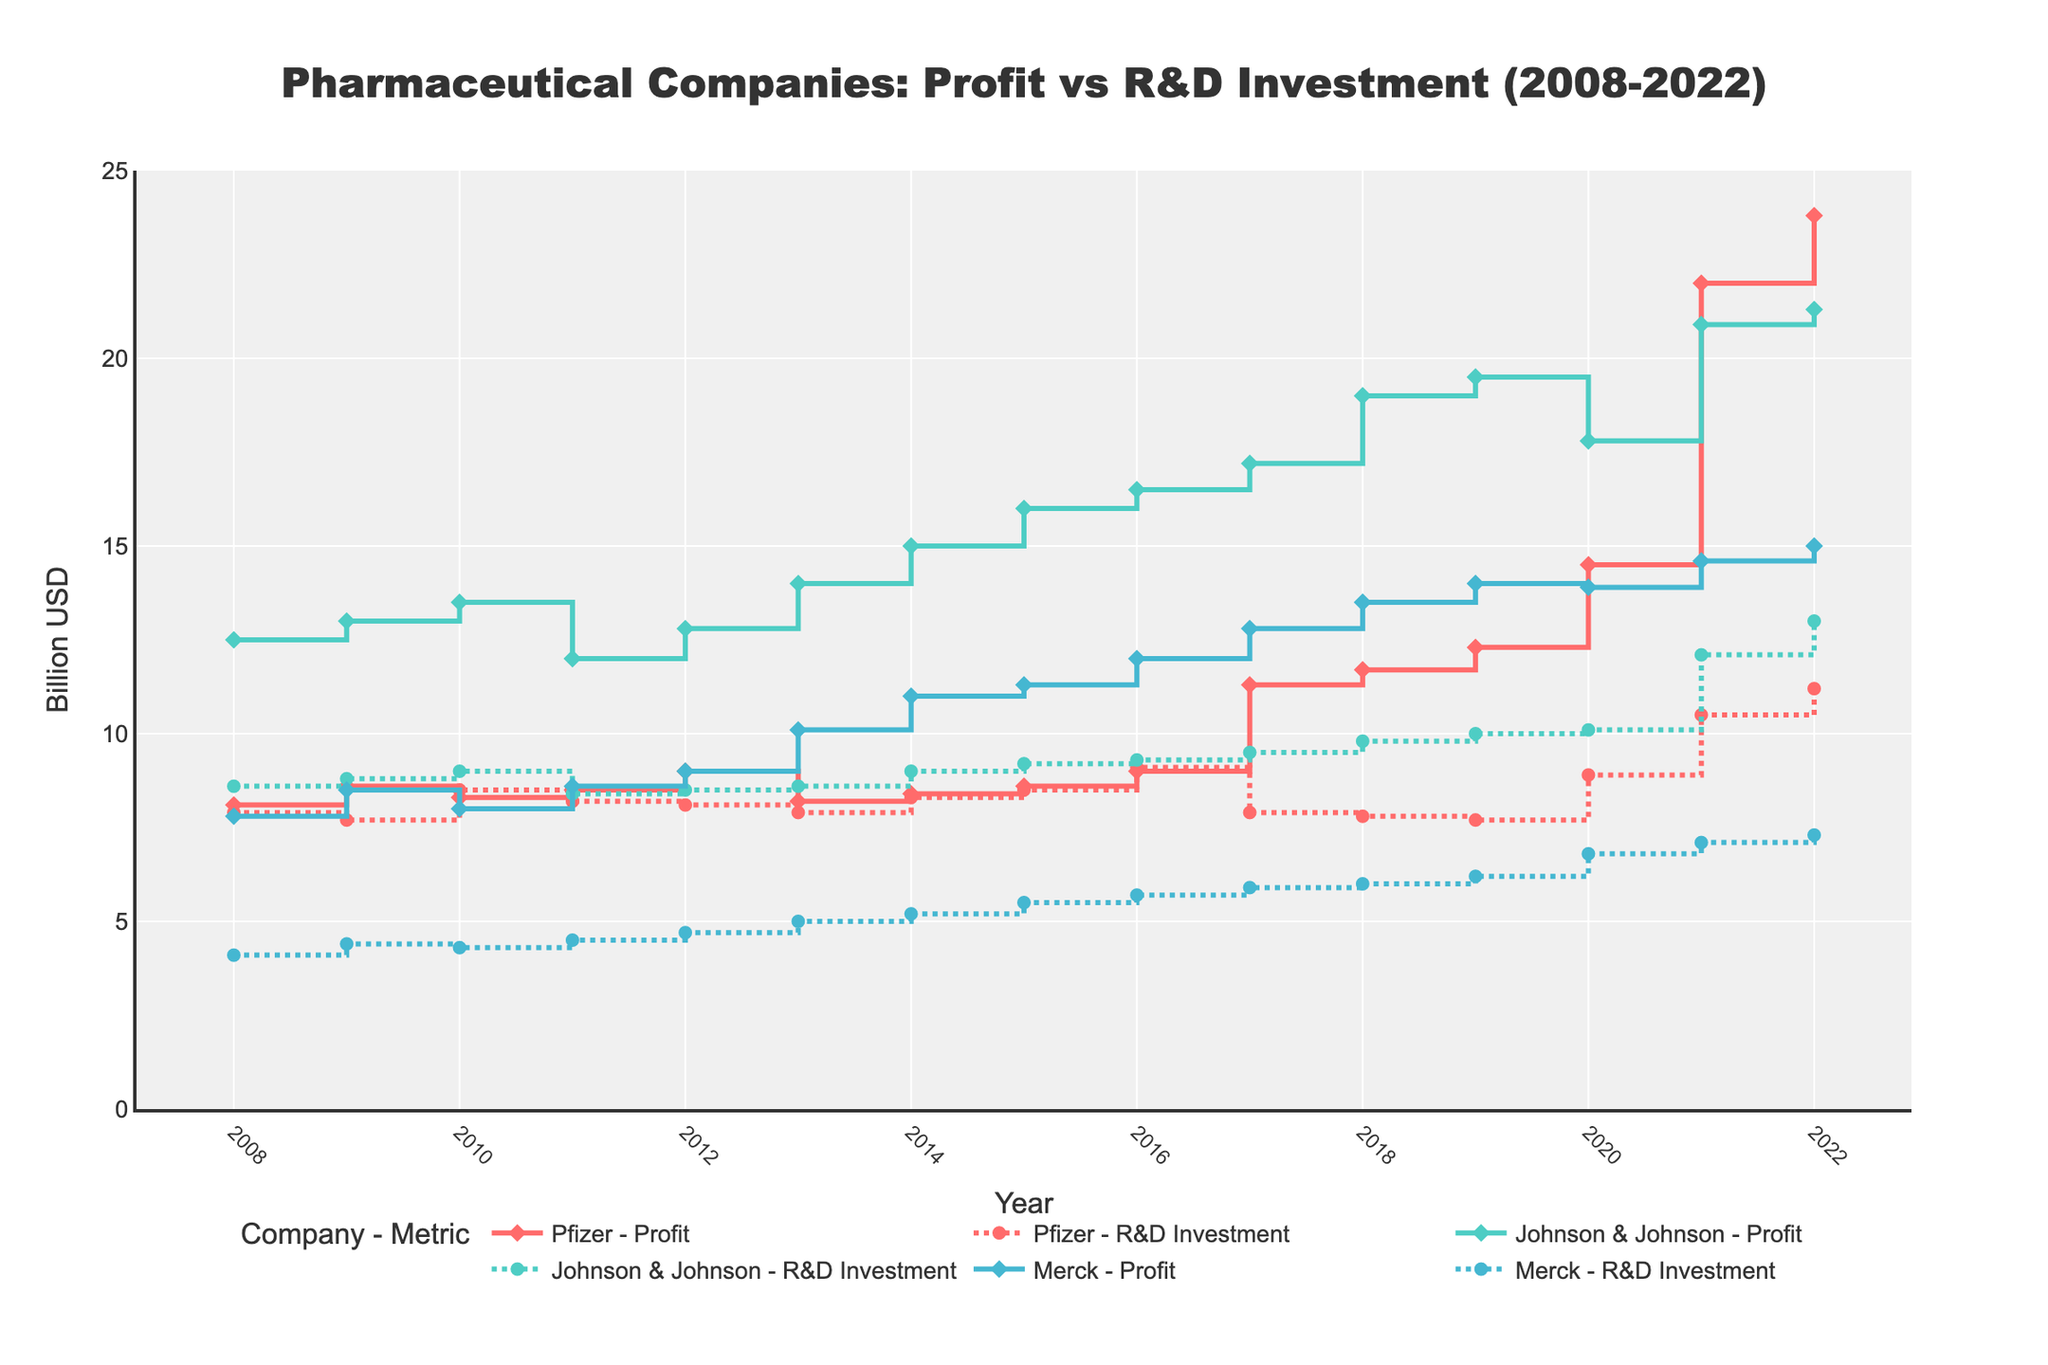How has Pfizer's profit evolved from 2008 to 2022? By examining the stair plot, Pfizer's profit begins at 8.1 billion USD in 2008 and gradually increases over the years. A significant jump can be seen after 2019, culminating in 23.8 billion USD in 2022.
Answer: It increased from 8.1 billion USD to 23.8 billion USD What trend can be observed in Johnson & Johnson's R&D investment between 2008 and 2022? The stair plot shows consistent growth in Johnson & Johnson's R&D investment over the years, starting at 8.6 billion USD in 2008 and rising to 13 billion USD by 2022.
Answer: It steadily increased from 8.6 billion USD to 13 billion USD Which company saw the largest increase in profits over this period? By comparing the stair plots of all companies, Pfizer's profit increased from 8.1 billion USD in 2008 to 23.8 billion USD in 2022, a rise of 15.7 billion USD. Johnson & Johnson and Merck had increases of 8.8 billion USD and 7.2 billion USD, respectively.
Answer: Pfizer How do the R&D investments of Merck compare with its profits in 2022? According to the stair plot, Merck's profit in 2022 is 15 billion USD, while its R&D investment is 7.3 billion USD.
Answer: Merck's R&D investment is lower than its profits in 2022 What year did Pfizer's R&D investment peak? By viewing the stair plot for Pfizer's R&D investments, it peaks in 2022 at 11.2 billion USD.
Answer: 2022 Between 2013 and 2014, which company's profits increased the most? The stair plot shows Pfizer's profit increasing from 8.2 billion USD to 8.4 billion USD (0.2 billion USD), Johnson & Johnson's from 14 billion USD to 15 billion USD (1 billion USD), and Merck's from 10.1 billion USD to 11 billion USD (0.9 billion USD).
Answer: Johnson & Johnson Compare the trends of profits and R&D investments of Johnson & Johnson from 2020 to 2022. Johnson & Johnson's profit rises from 17.8 billion USD in 2020 to 21.3 billion USD in 2022, while R&D investment increases from 10.1 billion USD to 13 billion USD, showing synchronous growth trends for both metrics.
Answer: Both increased Which year did all three companies have the highest combined R&D investment? By summing each year's R&D investments, the highest combined value appears in 2022. Pfizer (11.2 billion USD), Johnson & Johnson (13 billion USD), and Merck (7.3 billion USD) provide a total of 31.5 billion USD.
Answer: 2022 What is the average R&D investment for Merck over the period 2008-2022? Summing the R&D investments from 2008 (4.1 billion USD) to 2022 (7.3 billion USD) and dividing by the 15 years, give an average. Sum = 89.5 billion USD, average = 89.5/15 ≈ 5.97 billion USD.
Answer: ≈ 5.97 billion USD In which year did Pfizer's profit first surpass 10 billion USD? According to the stair plot, Pfizer's profit surpassed 10 billion USD for the first time in 2017, reaching 11.3 billion USD.
Answer: 2017 